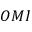<formula> <loc_0><loc_0><loc_500><loc_500>O M I</formula> 